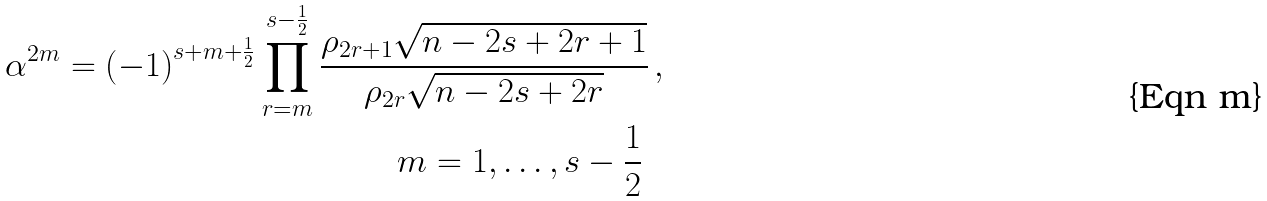<formula> <loc_0><loc_0><loc_500><loc_500>\alpha ^ { 2 m } = \left ( - 1 \right ) ^ { s + m + \frac { 1 } { 2 } } \prod _ { r = m } ^ { s - \frac { 1 } { 2 } } \frac { \rho _ { 2 r + 1 } \sqrt { n - 2 s + 2 r + 1 } } { \rho _ { 2 r } \sqrt { n - 2 s + 2 r } } & \, , \\ m = 1 , \dots , s - \frac { 1 } { 2 } \, &</formula> 